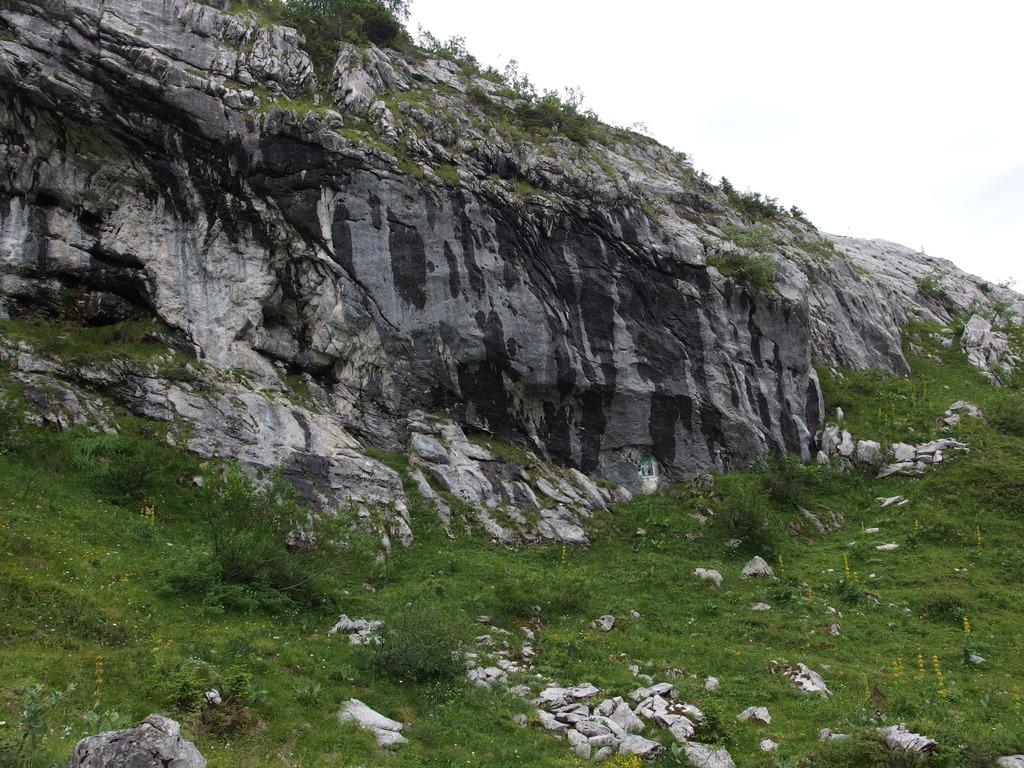What type of vegetation is present on the ground in the image? There is grass and plants on the ground in the image. What geographical feature can be seen in the image? There is a hill in the image. What is visible in the background of the image? The sky is visible in the background of the image. What type of meat is being grilled on the hill in the image? There is no meat or grill present in the image; it features grass, plants, and a hill. How many zebras can be seen grazing on the grass in the image? There are no zebras present in the image; it only features grass, plants, and a hill. 